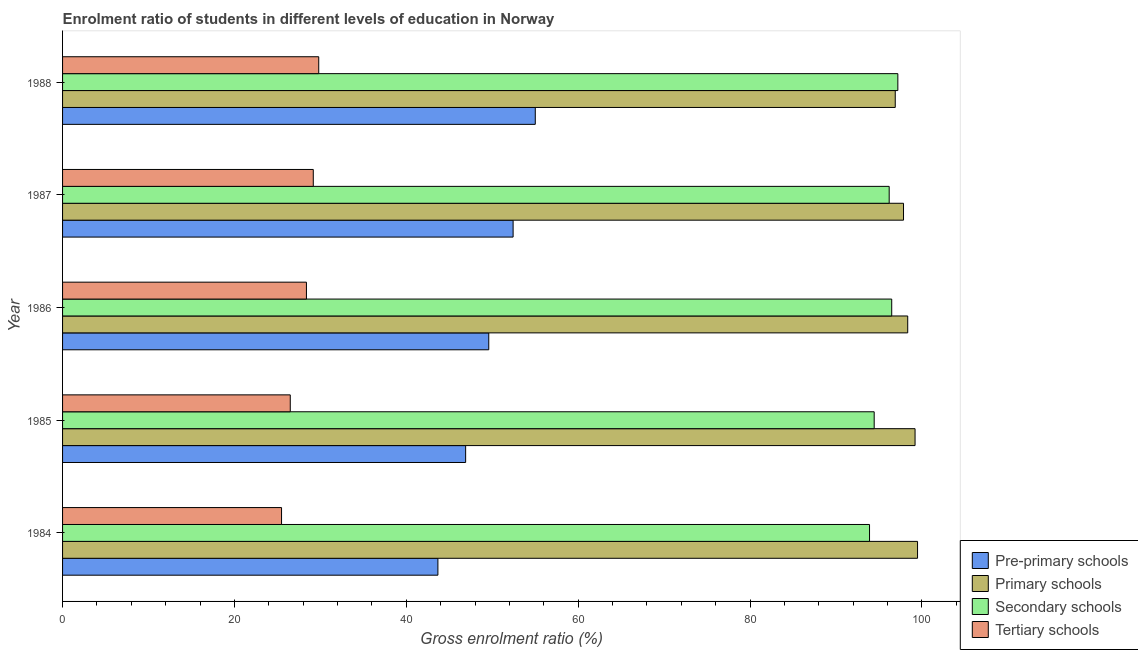How many different coloured bars are there?
Make the answer very short. 4. Are the number of bars per tick equal to the number of legend labels?
Make the answer very short. Yes. Are the number of bars on each tick of the Y-axis equal?
Ensure brevity in your answer.  Yes. How many bars are there on the 5th tick from the top?
Your answer should be very brief. 4. What is the gross enrolment ratio in pre-primary schools in 1985?
Give a very brief answer. 46.9. Across all years, what is the maximum gross enrolment ratio in secondary schools?
Offer a terse response. 97.2. Across all years, what is the minimum gross enrolment ratio in pre-primary schools?
Give a very brief answer. 43.68. In which year was the gross enrolment ratio in secondary schools minimum?
Keep it short and to the point. 1984. What is the total gross enrolment ratio in secondary schools in the graph?
Your response must be concise. 478.23. What is the difference between the gross enrolment ratio in tertiary schools in 1984 and that in 1986?
Provide a succinct answer. -2.9. What is the difference between the gross enrolment ratio in tertiary schools in 1984 and the gross enrolment ratio in pre-primary schools in 1988?
Your answer should be compact. -29.53. What is the average gross enrolment ratio in pre-primary schools per year?
Make the answer very short. 49.52. In the year 1988, what is the difference between the gross enrolment ratio in tertiary schools and gross enrolment ratio in pre-primary schools?
Your answer should be compact. -25.2. What is the ratio of the gross enrolment ratio in primary schools in 1984 to that in 1988?
Offer a very short reply. 1.03. What is the difference between the highest and the second highest gross enrolment ratio in secondary schools?
Offer a terse response. 0.71. What is the difference between the highest and the lowest gross enrolment ratio in secondary schools?
Your answer should be compact. 3.29. Is it the case that in every year, the sum of the gross enrolment ratio in tertiary schools and gross enrolment ratio in pre-primary schools is greater than the sum of gross enrolment ratio in secondary schools and gross enrolment ratio in primary schools?
Provide a succinct answer. No. What does the 1st bar from the top in 1985 represents?
Keep it short and to the point. Tertiary schools. What does the 3rd bar from the bottom in 1986 represents?
Make the answer very short. Secondary schools. Is it the case that in every year, the sum of the gross enrolment ratio in pre-primary schools and gross enrolment ratio in primary schools is greater than the gross enrolment ratio in secondary schools?
Your response must be concise. Yes. How many bars are there?
Offer a very short reply. 20. Are the values on the major ticks of X-axis written in scientific E-notation?
Keep it short and to the point. No. Where does the legend appear in the graph?
Provide a succinct answer. Bottom right. How are the legend labels stacked?
Give a very brief answer. Vertical. What is the title of the graph?
Provide a succinct answer. Enrolment ratio of students in different levels of education in Norway. What is the label or title of the Y-axis?
Keep it short and to the point. Year. What is the Gross enrolment ratio (%) of Pre-primary schools in 1984?
Your response must be concise. 43.68. What is the Gross enrolment ratio (%) of Primary schools in 1984?
Give a very brief answer. 99.49. What is the Gross enrolment ratio (%) in Secondary schools in 1984?
Ensure brevity in your answer.  93.91. What is the Gross enrolment ratio (%) of Tertiary schools in 1984?
Provide a short and direct response. 25.48. What is the Gross enrolment ratio (%) of Pre-primary schools in 1985?
Provide a succinct answer. 46.9. What is the Gross enrolment ratio (%) of Primary schools in 1985?
Offer a terse response. 99.2. What is the Gross enrolment ratio (%) of Secondary schools in 1985?
Offer a very short reply. 94.45. What is the Gross enrolment ratio (%) of Tertiary schools in 1985?
Keep it short and to the point. 26.5. What is the Gross enrolment ratio (%) of Pre-primary schools in 1986?
Ensure brevity in your answer.  49.6. What is the Gross enrolment ratio (%) of Primary schools in 1986?
Provide a succinct answer. 98.35. What is the Gross enrolment ratio (%) in Secondary schools in 1986?
Keep it short and to the point. 96.49. What is the Gross enrolment ratio (%) in Tertiary schools in 1986?
Provide a short and direct response. 28.38. What is the Gross enrolment ratio (%) in Pre-primary schools in 1987?
Your answer should be very brief. 52.43. What is the Gross enrolment ratio (%) of Primary schools in 1987?
Offer a very short reply. 97.86. What is the Gross enrolment ratio (%) in Secondary schools in 1987?
Keep it short and to the point. 96.19. What is the Gross enrolment ratio (%) of Tertiary schools in 1987?
Offer a terse response. 29.17. What is the Gross enrolment ratio (%) of Pre-primary schools in 1988?
Your answer should be very brief. 55.01. What is the Gross enrolment ratio (%) in Primary schools in 1988?
Your response must be concise. 96.9. What is the Gross enrolment ratio (%) of Secondary schools in 1988?
Your answer should be very brief. 97.2. What is the Gross enrolment ratio (%) in Tertiary schools in 1988?
Offer a very short reply. 29.81. Across all years, what is the maximum Gross enrolment ratio (%) of Pre-primary schools?
Provide a succinct answer. 55.01. Across all years, what is the maximum Gross enrolment ratio (%) in Primary schools?
Your answer should be very brief. 99.49. Across all years, what is the maximum Gross enrolment ratio (%) of Secondary schools?
Your response must be concise. 97.2. Across all years, what is the maximum Gross enrolment ratio (%) of Tertiary schools?
Provide a short and direct response. 29.81. Across all years, what is the minimum Gross enrolment ratio (%) of Pre-primary schools?
Offer a very short reply. 43.68. Across all years, what is the minimum Gross enrolment ratio (%) of Primary schools?
Provide a short and direct response. 96.9. Across all years, what is the minimum Gross enrolment ratio (%) in Secondary schools?
Your answer should be compact. 93.91. Across all years, what is the minimum Gross enrolment ratio (%) in Tertiary schools?
Keep it short and to the point. 25.48. What is the total Gross enrolment ratio (%) in Pre-primary schools in the graph?
Your answer should be compact. 247.62. What is the total Gross enrolment ratio (%) of Primary schools in the graph?
Keep it short and to the point. 491.81. What is the total Gross enrolment ratio (%) in Secondary schools in the graph?
Offer a very short reply. 478.23. What is the total Gross enrolment ratio (%) in Tertiary schools in the graph?
Give a very brief answer. 139.34. What is the difference between the Gross enrolment ratio (%) of Pre-primary schools in 1984 and that in 1985?
Your answer should be very brief. -3.23. What is the difference between the Gross enrolment ratio (%) of Primary schools in 1984 and that in 1985?
Ensure brevity in your answer.  0.29. What is the difference between the Gross enrolment ratio (%) of Secondary schools in 1984 and that in 1985?
Provide a succinct answer. -0.54. What is the difference between the Gross enrolment ratio (%) in Tertiary schools in 1984 and that in 1985?
Your answer should be very brief. -1.01. What is the difference between the Gross enrolment ratio (%) of Pre-primary schools in 1984 and that in 1986?
Your answer should be compact. -5.92. What is the difference between the Gross enrolment ratio (%) of Primary schools in 1984 and that in 1986?
Keep it short and to the point. 1.14. What is the difference between the Gross enrolment ratio (%) of Secondary schools in 1984 and that in 1986?
Your answer should be compact. -2.58. What is the difference between the Gross enrolment ratio (%) in Tertiary schools in 1984 and that in 1986?
Ensure brevity in your answer.  -2.9. What is the difference between the Gross enrolment ratio (%) in Pre-primary schools in 1984 and that in 1987?
Keep it short and to the point. -8.75. What is the difference between the Gross enrolment ratio (%) in Primary schools in 1984 and that in 1987?
Your response must be concise. 1.63. What is the difference between the Gross enrolment ratio (%) in Secondary schools in 1984 and that in 1987?
Ensure brevity in your answer.  -2.29. What is the difference between the Gross enrolment ratio (%) of Tertiary schools in 1984 and that in 1987?
Your response must be concise. -3.69. What is the difference between the Gross enrolment ratio (%) in Pre-primary schools in 1984 and that in 1988?
Keep it short and to the point. -11.33. What is the difference between the Gross enrolment ratio (%) in Primary schools in 1984 and that in 1988?
Offer a terse response. 2.59. What is the difference between the Gross enrolment ratio (%) of Secondary schools in 1984 and that in 1988?
Make the answer very short. -3.29. What is the difference between the Gross enrolment ratio (%) in Tertiary schools in 1984 and that in 1988?
Provide a short and direct response. -4.33. What is the difference between the Gross enrolment ratio (%) in Pre-primary schools in 1985 and that in 1986?
Offer a terse response. -2.69. What is the difference between the Gross enrolment ratio (%) of Primary schools in 1985 and that in 1986?
Give a very brief answer. 0.85. What is the difference between the Gross enrolment ratio (%) of Secondary schools in 1985 and that in 1986?
Your answer should be compact. -2.04. What is the difference between the Gross enrolment ratio (%) in Tertiary schools in 1985 and that in 1986?
Keep it short and to the point. -1.88. What is the difference between the Gross enrolment ratio (%) in Pre-primary schools in 1985 and that in 1987?
Provide a succinct answer. -5.52. What is the difference between the Gross enrolment ratio (%) in Primary schools in 1985 and that in 1987?
Offer a very short reply. 1.34. What is the difference between the Gross enrolment ratio (%) in Secondary schools in 1985 and that in 1987?
Offer a very short reply. -1.75. What is the difference between the Gross enrolment ratio (%) in Tertiary schools in 1985 and that in 1987?
Keep it short and to the point. -2.68. What is the difference between the Gross enrolment ratio (%) in Pre-primary schools in 1985 and that in 1988?
Ensure brevity in your answer.  -8.1. What is the difference between the Gross enrolment ratio (%) of Primary schools in 1985 and that in 1988?
Offer a terse response. 2.31. What is the difference between the Gross enrolment ratio (%) of Secondary schools in 1985 and that in 1988?
Give a very brief answer. -2.75. What is the difference between the Gross enrolment ratio (%) in Tertiary schools in 1985 and that in 1988?
Your answer should be compact. -3.31. What is the difference between the Gross enrolment ratio (%) in Pre-primary schools in 1986 and that in 1987?
Give a very brief answer. -2.83. What is the difference between the Gross enrolment ratio (%) in Primary schools in 1986 and that in 1987?
Make the answer very short. 0.49. What is the difference between the Gross enrolment ratio (%) in Secondary schools in 1986 and that in 1987?
Offer a very short reply. 0.29. What is the difference between the Gross enrolment ratio (%) of Tertiary schools in 1986 and that in 1987?
Provide a succinct answer. -0.8. What is the difference between the Gross enrolment ratio (%) of Pre-primary schools in 1986 and that in 1988?
Keep it short and to the point. -5.41. What is the difference between the Gross enrolment ratio (%) of Primary schools in 1986 and that in 1988?
Provide a succinct answer. 1.45. What is the difference between the Gross enrolment ratio (%) of Secondary schools in 1986 and that in 1988?
Keep it short and to the point. -0.71. What is the difference between the Gross enrolment ratio (%) in Tertiary schools in 1986 and that in 1988?
Ensure brevity in your answer.  -1.43. What is the difference between the Gross enrolment ratio (%) in Pre-primary schools in 1987 and that in 1988?
Provide a short and direct response. -2.58. What is the difference between the Gross enrolment ratio (%) of Primary schools in 1987 and that in 1988?
Ensure brevity in your answer.  0.96. What is the difference between the Gross enrolment ratio (%) of Secondary schools in 1987 and that in 1988?
Make the answer very short. -1.01. What is the difference between the Gross enrolment ratio (%) in Tertiary schools in 1987 and that in 1988?
Ensure brevity in your answer.  -0.64. What is the difference between the Gross enrolment ratio (%) of Pre-primary schools in 1984 and the Gross enrolment ratio (%) of Primary schools in 1985?
Your answer should be compact. -55.53. What is the difference between the Gross enrolment ratio (%) in Pre-primary schools in 1984 and the Gross enrolment ratio (%) in Secondary schools in 1985?
Give a very brief answer. -50.77. What is the difference between the Gross enrolment ratio (%) in Pre-primary schools in 1984 and the Gross enrolment ratio (%) in Tertiary schools in 1985?
Provide a succinct answer. 17.18. What is the difference between the Gross enrolment ratio (%) in Primary schools in 1984 and the Gross enrolment ratio (%) in Secondary schools in 1985?
Make the answer very short. 5.04. What is the difference between the Gross enrolment ratio (%) in Primary schools in 1984 and the Gross enrolment ratio (%) in Tertiary schools in 1985?
Make the answer very short. 73. What is the difference between the Gross enrolment ratio (%) of Secondary schools in 1984 and the Gross enrolment ratio (%) of Tertiary schools in 1985?
Your answer should be compact. 67.41. What is the difference between the Gross enrolment ratio (%) in Pre-primary schools in 1984 and the Gross enrolment ratio (%) in Primary schools in 1986?
Keep it short and to the point. -54.67. What is the difference between the Gross enrolment ratio (%) in Pre-primary schools in 1984 and the Gross enrolment ratio (%) in Secondary schools in 1986?
Ensure brevity in your answer.  -52.81. What is the difference between the Gross enrolment ratio (%) in Pre-primary schools in 1984 and the Gross enrolment ratio (%) in Tertiary schools in 1986?
Your answer should be compact. 15.3. What is the difference between the Gross enrolment ratio (%) in Primary schools in 1984 and the Gross enrolment ratio (%) in Secondary schools in 1986?
Keep it short and to the point. 3.01. What is the difference between the Gross enrolment ratio (%) in Primary schools in 1984 and the Gross enrolment ratio (%) in Tertiary schools in 1986?
Your response must be concise. 71.11. What is the difference between the Gross enrolment ratio (%) in Secondary schools in 1984 and the Gross enrolment ratio (%) in Tertiary schools in 1986?
Give a very brief answer. 65.53. What is the difference between the Gross enrolment ratio (%) in Pre-primary schools in 1984 and the Gross enrolment ratio (%) in Primary schools in 1987?
Your answer should be compact. -54.18. What is the difference between the Gross enrolment ratio (%) of Pre-primary schools in 1984 and the Gross enrolment ratio (%) of Secondary schools in 1987?
Offer a very short reply. -52.51. What is the difference between the Gross enrolment ratio (%) of Pre-primary schools in 1984 and the Gross enrolment ratio (%) of Tertiary schools in 1987?
Ensure brevity in your answer.  14.5. What is the difference between the Gross enrolment ratio (%) of Primary schools in 1984 and the Gross enrolment ratio (%) of Secondary schools in 1987?
Provide a short and direct response. 3.3. What is the difference between the Gross enrolment ratio (%) of Primary schools in 1984 and the Gross enrolment ratio (%) of Tertiary schools in 1987?
Provide a succinct answer. 70.32. What is the difference between the Gross enrolment ratio (%) in Secondary schools in 1984 and the Gross enrolment ratio (%) in Tertiary schools in 1987?
Provide a short and direct response. 64.73. What is the difference between the Gross enrolment ratio (%) of Pre-primary schools in 1984 and the Gross enrolment ratio (%) of Primary schools in 1988?
Offer a terse response. -53.22. What is the difference between the Gross enrolment ratio (%) in Pre-primary schools in 1984 and the Gross enrolment ratio (%) in Secondary schools in 1988?
Offer a very short reply. -53.52. What is the difference between the Gross enrolment ratio (%) in Pre-primary schools in 1984 and the Gross enrolment ratio (%) in Tertiary schools in 1988?
Your answer should be very brief. 13.87. What is the difference between the Gross enrolment ratio (%) of Primary schools in 1984 and the Gross enrolment ratio (%) of Secondary schools in 1988?
Make the answer very short. 2.29. What is the difference between the Gross enrolment ratio (%) in Primary schools in 1984 and the Gross enrolment ratio (%) in Tertiary schools in 1988?
Keep it short and to the point. 69.68. What is the difference between the Gross enrolment ratio (%) of Secondary schools in 1984 and the Gross enrolment ratio (%) of Tertiary schools in 1988?
Provide a short and direct response. 64.1. What is the difference between the Gross enrolment ratio (%) of Pre-primary schools in 1985 and the Gross enrolment ratio (%) of Primary schools in 1986?
Your response must be concise. -51.45. What is the difference between the Gross enrolment ratio (%) of Pre-primary schools in 1985 and the Gross enrolment ratio (%) of Secondary schools in 1986?
Offer a very short reply. -49.58. What is the difference between the Gross enrolment ratio (%) in Pre-primary schools in 1985 and the Gross enrolment ratio (%) in Tertiary schools in 1986?
Offer a terse response. 18.53. What is the difference between the Gross enrolment ratio (%) in Primary schools in 1985 and the Gross enrolment ratio (%) in Secondary schools in 1986?
Make the answer very short. 2.72. What is the difference between the Gross enrolment ratio (%) in Primary schools in 1985 and the Gross enrolment ratio (%) in Tertiary schools in 1986?
Your response must be concise. 70.82. What is the difference between the Gross enrolment ratio (%) in Secondary schools in 1985 and the Gross enrolment ratio (%) in Tertiary schools in 1986?
Ensure brevity in your answer.  66.07. What is the difference between the Gross enrolment ratio (%) of Pre-primary schools in 1985 and the Gross enrolment ratio (%) of Primary schools in 1987?
Offer a terse response. -50.96. What is the difference between the Gross enrolment ratio (%) of Pre-primary schools in 1985 and the Gross enrolment ratio (%) of Secondary schools in 1987?
Your answer should be very brief. -49.29. What is the difference between the Gross enrolment ratio (%) of Pre-primary schools in 1985 and the Gross enrolment ratio (%) of Tertiary schools in 1987?
Your response must be concise. 17.73. What is the difference between the Gross enrolment ratio (%) in Primary schools in 1985 and the Gross enrolment ratio (%) in Secondary schools in 1987?
Your answer should be very brief. 3.01. What is the difference between the Gross enrolment ratio (%) in Primary schools in 1985 and the Gross enrolment ratio (%) in Tertiary schools in 1987?
Give a very brief answer. 70.03. What is the difference between the Gross enrolment ratio (%) in Secondary schools in 1985 and the Gross enrolment ratio (%) in Tertiary schools in 1987?
Provide a short and direct response. 65.27. What is the difference between the Gross enrolment ratio (%) of Pre-primary schools in 1985 and the Gross enrolment ratio (%) of Primary schools in 1988?
Offer a very short reply. -49.99. What is the difference between the Gross enrolment ratio (%) of Pre-primary schools in 1985 and the Gross enrolment ratio (%) of Secondary schools in 1988?
Make the answer very short. -50.3. What is the difference between the Gross enrolment ratio (%) in Pre-primary schools in 1985 and the Gross enrolment ratio (%) in Tertiary schools in 1988?
Provide a succinct answer. 17.09. What is the difference between the Gross enrolment ratio (%) of Primary schools in 1985 and the Gross enrolment ratio (%) of Secondary schools in 1988?
Your response must be concise. 2. What is the difference between the Gross enrolment ratio (%) in Primary schools in 1985 and the Gross enrolment ratio (%) in Tertiary schools in 1988?
Give a very brief answer. 69.39. What is the difference between the Gross enrolment ratio (%) in Secondary schools in 1985 and the Gross enrolment ratio (%) in Tertiary schools in 1988?
Keep it short and to the point. 64.64. What is the difference between the Gross enrolment ratio (%) in Pre-primary schools in 1986 and the Gross enrolment ratio (%) in Primary schools in 1987?
Your answer should be compact. -48.27. What is the difference between the Gross enrolment ratio (%) in Pre-primary schools in 1986 and the Gross enrolment ratio (%) in Secondary schools in 1987?
Offer a terse response. -46.6. What is the difference between the Gross enrolment ratio (%) in Pre-primary schools in 1986 and the Gross enrolment ratio (%) in Tertiary schools in 1987?
Your response must be concise. 20.42. What is the difference between the Gross enrolment ratio (%) of Primary schools in 1986 and the Gross enrolment ratio (%) of Secondary schools in 1987?
Make the answer very short. 2.16. What is the difference between the Gross enrolment ratio (%) of Primary schools in 1986 and the Gross enrolment ratio (%) of Tertiary schools in 1987?
Offer a terse response. 69.18. What is the difference between the Gross enrolment ratio (%) of Secondary schools in 1986 and the Gross enrolment ratio (%) of Tertiary schools in 1987?
Make the answer very short. 67.31. What is the difference between the Gross enrolment ratio (%) in Pre-primary schools in 1986 and the Gross enrolment ratio (%) in Primary schools in 1988?
Your answer should be very brief. -47.3. What is the difference between the Gross enrolment ratio (%) of Pre-primary schools in 1986 and the Gross enrolment ratio (%) of Secondary schools in 1988?
Your answer should be compact. -47.6. What is the difference between the Gross enrolment ratio (%) in Pre-primary schools in 1986 and the Gross enrolment ratio (%) in Tertiary schools in 1988?
Provide a succinct answer. 19.79. What is the difference between the Gross enrolment ratio (%) of Primary schools in 1986 and the Gross enrolment ratio (%) of Secondary schools in 1988?
Make the answer very short. 1.15. What is the difference between the Gross enrolment ratio (%) in Primary schools in 1986 and the Gross enrolment ratio (%) in Tertiary schools in 1988?
Make the answer very short. 68.54. What is the difference between the Gross enrolment ratio (%) of Secondary schools in 1986 and the Gross enrolment ratio (%) of Tertiary schools in 1988?
Your answer should be very brief. 66.68. What is the difference between the Gross enrolment ratio (%) in Pre-primary schools in 1987 and the Gross enrolment ratio (%) in Primary schools in 1988?
Your response must be concise. -44.47. What is the difference between the Gross enrolment ratio (%) in Pre-primary schools in 1987 and the Gross enrolment ratio (%) in Secondary schools in 1988?
Provide a succinct answer. -44.77. What is the difference between the Gross enrolment ratio (%) of Pre-primary schools in 1987 and the Gross enrolment ratio (%) of Tertiary schools in 1988?
Provide a short and direct response. 22.62. What is the difference between the Gross enrolment ratio (%) in Primary schools in 1987 and the Gross enrolment ratio (%) in Secondary schools in 1988?
Give a very brief answer. 0.66. What is the difference between the Gross enrolment ratio (%) of Primary schools in 1987 and the Gross enrolment ratio (%) of Tertiary schools in 1988?
Your response must be concise. 68.05. What is the difference between the Gross enrolment ratio (%) in Secondary schools in 1987 and the Gross enrolment ratio (%) in Tertiary schools in 1988?
Offer a terse response. 66.38. What is the average Gross enrolment ratio (%) of Pre-primary schools per year?
Your answer should be compact. 49.52. What is the average Gross enrolment ratio (%) of Primary schools per year?
Your answer should be very brief. 98.36. What is the average Gross enrolment ratio (%) of Secondary schools per year?
Keep it short and to the point. 95.65. What is the average Gross enrolment ratio (%) in Tertiary schools per year?
Your answer should be very brief. 27.87. In the year 1984, what is the difference between the Gross enrolment ratio (%) in Pre-primary schools and Gross enrolment ratio (%) in Primary schools?
Offer a very short reply. -55.81. In the year 1984, what is the difference between the Gross enrolment ratio (%) in Pre-primary schools and Gross enrolment ratio (%) in Secondary schools?
Keep it short and to the point. -50.23. In the year 1984, what is the difference between the Gross enrolment ratio (%) of Pre-primary schools and Gross enrolment ratio (%) of Tertiary schools?
Keep it short and to the point. 18.19. In the year 1984, what is the difference between the Gross enrolment ratio (%) of Primary schools and Gross enrolment ratio (%) of Secondary schools?
Offer a terse response. 5.59. In the year 1984, what is the difference between the Gross enrolment ratio (%) of Primary schools and Gross enrolment ratio (%) of Tertiary schools?
Offer a terse response. 74.01. In the year 1984, what is the difference between the Gross enrolment ratio (%) in Secondary schools and Gross enrolment ratio (%) in Tertiary schools?
Your answer should be compact. 68.42. In the year 1985, what is the difference between the Gross enrolment ratio (%) of Pre-primary schools and Gross enrolment ratio (%) of Primary schools?
Your answer should be very brief. -52.3. In the year 1985, what is the difference between the Gross enrolment ratio (%) of Pre-primary schools and Gross enrolment ratio (%) of Secondary schools?
Provide a succinct answer. -47.54. In the year 1985, what is the difference between the Gross enrolment ratio (%) of Pre-primary schools and Gross enrolment ratio (%) of Tertiary schools?
Ensure brevity in your answer.  20.41. In the year 1985, what is the difference between the Gross enrolment ratio (%) in Primary schools and Gross enrolment ratio (%) in Secondary schools?
Give a very brief answer. 4.76. In the year 1985, what is the difference between the Gross enrolment ratio (%) in Primary schools and Gross enrolment ratio (%) in Tertiary schools?
Keep it short and to the point. 72.71. In the year 1985, what is the difference between the Gross enrolment ratio (%) in Secondary schools and Gross enrolment ratio (%) in Tertiary schools?
Ensure brevity in your answer.  67.95. In the year 1986, what is the difference between the Gross enrolment ratio (%) of Pre-primary schools and Gross enrolment ratio (%) of Primary schools?
Give a very brief answer. -48.75. In the year 1986, what is the difference between the Gross enrolment ratio (%) in Pre-primary schools and Gross enrolment ratio (%) in Secondary schools?
Ensure brevity in your answer.  -46.89. In the year 1986, what is the difference between the Gross enrolment ratio (%) of Pre-primary schools and Gross enrolment ratio (%) of Tertiary schools?
Provide a short and direct response. 21.22. In the year 1986, what is the difference between the Gross enrolment ratio (%) of Primary schools and Gross enrolment ratio (%) of Secondary schools?
Provide a short and direct response. 1.86. In the year 1986, what is the difference between the Gross enrolment ratio (%) in Primary schools and Gross enrolment ratio (%) in Tertiary schools?
Provide a short and direct response. 69.97. In the year 1986, what is the difference between the Gross enrolment ratio (%) of Secondary schools and Gross enrolment ratio (%) of Tertiary schools?
Offer a terse response. 68.11. In the year 1987, what is the difference between the Gross enrolment ratio (%) of Pre-primary schools and Gross enrolment ratio (%) of Primary schools?
Provide a succinct answer. -45.43. In the year 1987, what is the difference between the Gross enrolment ratio (%) in Pre-primary schools and Gross enrolment ratio (%) in Secondary schools?
Provide a succinct answer. -43.76. In the year 1987, what is the difference between the Gross enrolment ratio (%) of Pre-primary schools and Gross enrolment ratio (%) of Tertiary schools?
Offer a very short reply. 23.25. In the year 1987, what is the difference between the Gross enrolment ratio (%) in Primary schools and Gross enrolment ratio (%) in Secondary schools?
Offer a terse response. 1.67. In the year 1987, what is the difference between the Gross enrolment ratio (%) of Primary schools and Gross enrolment ratio (%) of Tertiary schools?
Your answer should be very brief. 68.69. In the year 1987, what is the difference between the Gross enrolment ratio (%) in Secondary schools and Gross enrolment ratio (%) in Tertiary schools?
Make the answer very short. 67.02. In the year 1988, what is the difference between the Gross enrolment ratio (%) in Pre-primary schools and Gross enrolment ratio (%) in Primary schools?
Ensure brevity in your answer.  -41.89. In the year 1988, what is the difference between the Gross enrolment ratio (%) in Pre-primary schools and Gross enrolment ratio (%) in Secondary schools?
Give a very brief answer. -42.19. In the year 1988, what is the difference between the Gross enrolment ratio (%) in Pre-primary schools and Gross enrolment ratio (%) in Tertiary schools?
Your answer should be very brief. 25.2. In the year 1988, what is the difference between the Gross enrolment ratio (%) of Primary schools and Gross enrolment ratio (%) of Secondary schools?
Your answer should be compact. -0.3. In the year 1988, what is the difference between the Gross enrolment ratio (%) of Primary schools and Gross enrolment ratio (%) of Tertiary schools?
Provide a succinct answer. 67.09. In the year 1988, what is the difference between the Gross enrolment ratio (%) in Secondary schools and Gross enrolment ratio (%) in Tertiary schools?
Your response must be concise. 67.39. What is the ratio of the Gross enrolment ratio (%) in Pre-primary schools in 1984 to that in 1985?
Ensure brevity in your answer.  0.93. What is the ratio of the Gross enrolment ratio (%) in Secondary schools in 1984 to that in 1985?
Your response must be concise. 0.99. What is the ratio of the Gross enrolment ratio (%) of Tertiary schools in 1984 to that in 1985?
Provide a succinct answer. 0.96. What is the ratio of the Gross enrolment ratio (%) of Pre-primary schools in 1984 to that in 1986?
Your answer should be very brief. 0.88. What is the ratio of the Gross enrolment ratio (%) in Primary schools in 1984 to that in 1986?
Keep it short and to the point. 1.01. What is the ratio of the Gross enrolment ratio (%) in Secondary schools in 1984 to that in 1986?
Give a very brief answer. 0.97. What is the ratio of the Gross enrolment ratio (%) in Tertiary schools in 1984 to that in 1986?
Provide a short and direct response. 0.9. What is the ratio of the Gross enrolment ratio (%) of Pre-primary schools in 1984 to that in 1987?
Ensure brevity in your answer.  0.83. What is the ratio of the Gross enrolment ratio (%) in Primary schools in 1984 to that in 1987?
Give a very brief answer. 1.02. What is the ratio of the Gross enrolment ratio (%) in Secondary schools in 1984 to that in 1987?
Give a very brief answer. 0.98. What is the ratio of the Gross enrolment ratio (%) of Tertiary schools in 1984 to that in 1987?
Make the answer very short. 0.87. What is the ratio of the Gross enrolment ratio (%) of Pre-primary schools in 1984 to that in 1988?
Ensure brevity in your answer.  0.79. What is the ratio of the Gross enrolment ratio (%) in Primary schools in 1984 to that in 1988?
Make the answer very short. 1.03. What is the ratio of the Gross enrolment ratio (%) in Secondary schools in 1984 to that in 1988?
Your answer should be compact. 0.97. What is the ratio of the Gross enrolment ratio (%) of Tertiary schools in 1984 to that in 1988?
Your answer should be compact. 0.85. What is the ratio of the Gross enrolment ratio (%) of Pre-primary schools in 1985 to that in 1986?
Make the answer very short. 0.95. What is the ratio of the Gross enrolment ratio (%) of Primary schools in 1985 to that in 1986?
Provide a succinct answer. 1.01. What is the ratio of the Gross enrolment ratio (%) of Secondary schools in 1985 to that in 1986?
Offer a very short reply. 0.98. What is the ratio of the Gross enrolment ratio (%) in Tertiary schools in 1985 to that in 1986?
Provide a succinct answer. 0.93. What is the ratio of the Gross enrolment ratio (%) in Pre-primary schools in 1985 to that in 1987?
Provide a short and direct response. 0.89. What is the ratio of the Gross enrolment ratio (%) of Primary schools in 1985 to that in 1987?
Offer a very short reply. 1.01. What is the ratio of the Gross enrolment ratio (%) in Secondary schools in 1985 to that in 1987?
Give a very brief answer. 0.98. What is the ratio of the Gross enrolment ratio (%) of Tertiary schools in 1985 to that in 1987?
Your response must be concise. 0.91. What is the ratio of the Gross enrolment ratio (%) of Pre-primary schools in 1985 to that in 1988?
Provide a short and direct response. 0.85. What is the ratio of the Gross enrolment ratio (%) in Primary schools in 1985 to that in 1988?
Provide a short and direct response. 1.02. What is the ratio of the Gross enrolment ratio (%) in Secondary schools in 1985 to that in 1988?
Provide a short and direct response. 0.97. What is the ratio of the Gross enrolment ratio (%) in Tertiary schools in 1985 to that in 1988?
Offer a terse response. 0.89. What is the ratio of the Gross enrolment ratio (%) in Pre-primary schools in 1986 to that in 1987?
Your answer should be very brief. 0.95. What is the ratio of the Gross enrolment ratio (%) of Primary schools in 1986 to that in 1987?
Offer a terse response. 1. What is the ratio of the Gross enrolment ratio (%) of Tertiary schools in 1986 to that in 1987?
Make the answer very short. 0.97. What is the ratio of the Gross enrolment ratio (%) in Pre-primary schools in 1986 to that in 1988?
Make the answer very short. 0.9. What is the ratio of the Gross enrolment ratio (%) in Tertiary schools in 1986 to that in 1988?
Keep it short and to the point. 0.95. What is the ratio of the Gross enrolment ratio (%) of Pre-primary schools in 1987 to that in 1988?
Provide a short and direct response. 0.95. What is the ratio of the Gross enrolment ratio (%) in Primary schools in 1987 to that in 1988?
Offer a terse response. 1.01. What is the ratio of the Gross enrolment ratio (%) in Tertiary schools in 1987 to that in 1988?
Your answer should be very brief. 0.98. What is the difference between the highest and the second highest Gross enrolment ratio (%) in Pre-primary schools?
Provide a succinct answer. 2.58. What is the difference between the highest and the second highest Gross enrolment ratio (%) of Primary schools?
Your answer should be very brief. 0.29. What is the difference between the highest and the second highest Gross enrolment ratio (%) of Secondary schools?
Provide a succinct answer. 0.71. What is the difference between the highest and the second highest Gross enrolment ratio (%) of Tertiary schools?
Ensure brevity in your answer.  0.64. What is the difference between the highest and the lowest Gross enrolment ratio (%) in Pre-primary schools?
Make the answer very short. 11.33. What is the difference between the highest and the lowest Gross enrolment ratio (%) in Primary schools?
Ensure brevity in your answer.  2.59. What is the difference between the highest and the lowest Gross enrolment ratio (%) of Secondary schools?
Provide a short and direct response. 3.29. What is the difference between the highest and the lowest Gross enrolment ratio (%) in Tertiary schools?
Your answer should be very brief. 4.33. 